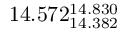<formula> <loc_0><loc_0><loc_500><loc_500>1 4 . 5 7 2 _ { 1 4 . 3 8 2 } ^ { 1 4 . 8 3 0 }</formula> 